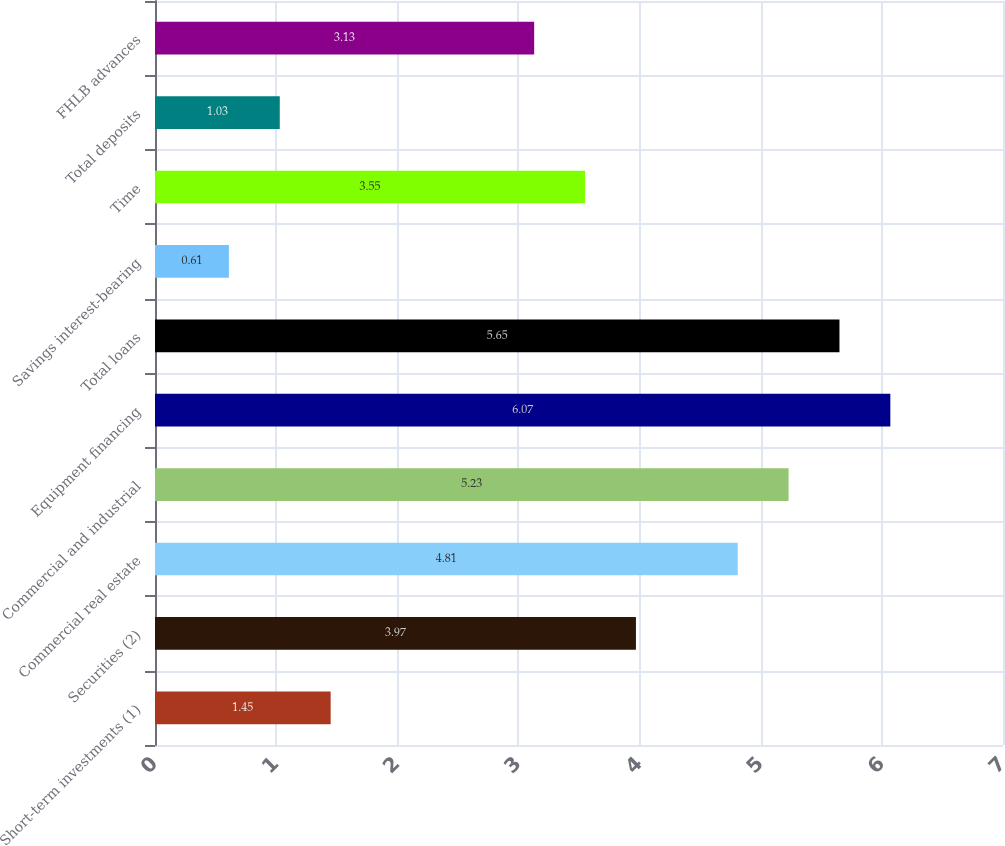Convert chart. <chart><loc_0><loc_0><loc_500><loc_500><bar_chart><fcel>Short-term investments (1)<fcel>Securities (2)<fcel>Commercial real estate<fcel>Commercial and industrial<fcel>Equipment financing<fcel>Total loans<fcel>Savings interest-bearing<fcel>Time<fcel>Total deposits<fcel>FHLB advances<nl><fcel>1.45<fcel>3.97<fcel>4.81<fcel>5.23<fcel>6.07<fcel>5.65<fcel>0.61<fcel>3.55<fcel>1.03<fcel>3.13<nl></chart> 